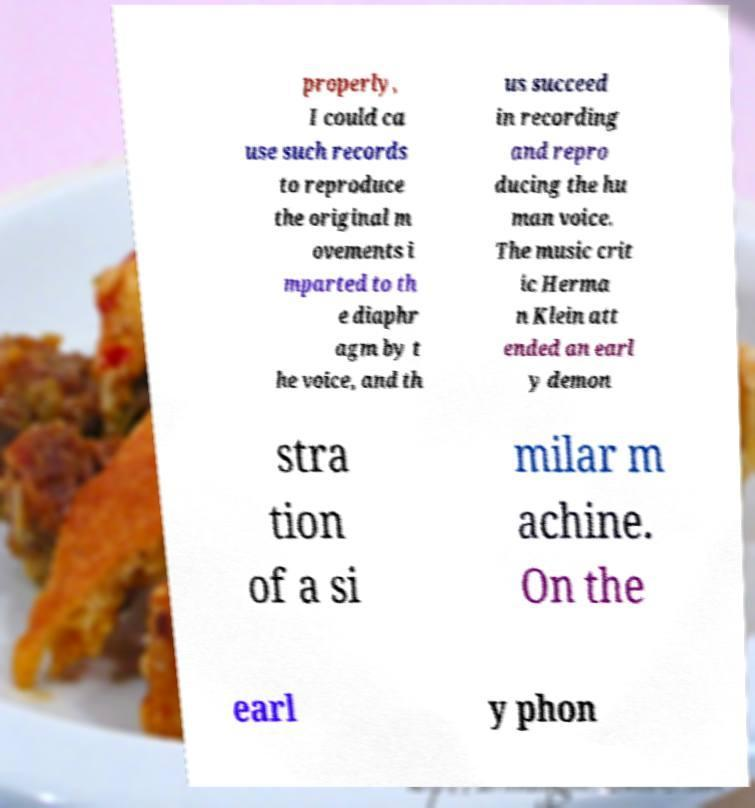There's text embedded in this image that I need extracted. Can you transcribe it verbatim? properly, I could ca use such records to reproduce the original m ovements i mparted to th e diaphr agm by t he voice, and th us succeed in recording and repro ducing the hu man voice. The music crit ic Herma n Klein att ended an earl y demon stra tion of a si milar m achine. On the earl y phon 